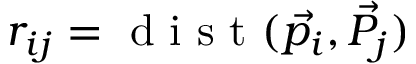<formula> <loc_0><loc_0><loc_500><loc_500>r _ { i j } = d i s t ( \vec { p _ { i } } , \vec { P _ { j } } )</formula> 